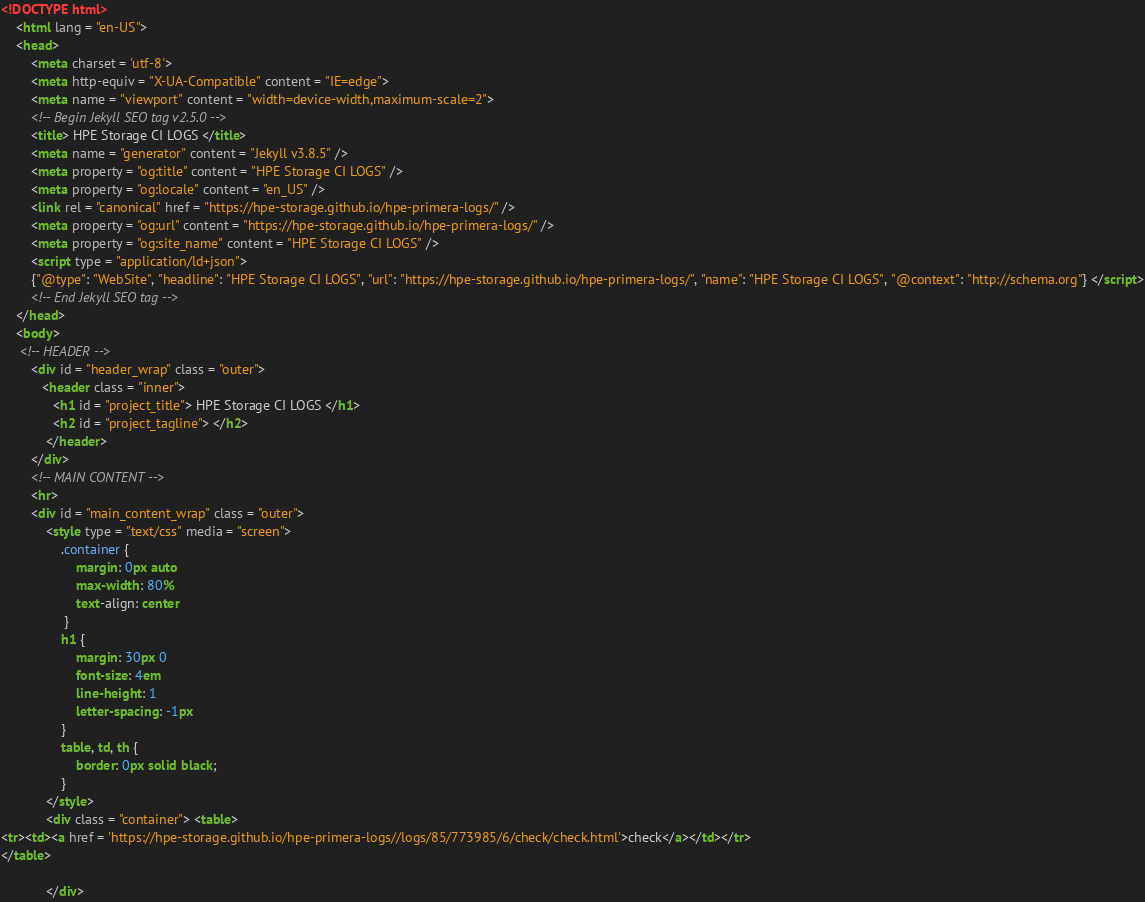Convert code to text. <code><loc_0><loc_0><loc_500><loc_500><_HTML_>
<!DOCTYPE html>
    <html lang = "en-US">
    <head>
        <meta charset = 'utf-8'>
        <meta http-equiv = "X-UA-Compatible" content = "IE=edge">
        <meta name = "viewport" content = "width=device-width,maximum-scale=2">
        <!-- Begin Jekyll SEO tag v2.5.0 -->
        <title> HPE Storage CI LOGS </title>
        <meta name = "generator" content = "Jekyll v3.8.5" />
        <meta property = "og:title" content = "HPE Storage CI LOGS" />
        <meta property = "og:locale" content = "en_US" />
        <link rel = "canonical" href = "https://hpe-storage.github.io/hpe-primera-logs/" />
        <meta property = "og:url" content = "https://hpe-storage.github.io/hpe-primera-logs/" />
        <meta property = "og:site_name" content = "HPE Storage CI LOGS" />
        <script type = "application/ld+json">
        {"@type": "WebSite", "headline": "HPE Storage CI LOGS", "url": "https://hpe-storage.github.io/hpe-primera-logs/", "name": "HPE Storage CI LOGS", "@context": "http://schema.org"} </script>
        <!-- End Jekyll SEO tag -->
    </head>
    <body>
     <!-- HEADER -->
        <div id = "header_wrap" class = "outer">
           <header class = "inner">
              <h1 id = "project_title"> HPE Storage CI LOGS </h1>
              <h2 id = "project_tagline"> </h2>
            </header>
        </div>
        <!-- MAIN CONTENT -->
        <hr>
        <div id = "main_content_wrap" class = "outer">
            <style type = "text/css" media = "screen">
                .container {
                    margin: 0px auto
                    max-width: 80%
                    text-align: center
                 }
                h1 {
                    margin: 30px 0
                    font-size: 4em
                    line-height: 1
                    letter-spacing: -1px
                }
                table, td, th {
                    border: 0px solid black;
                }
            </style>
            <div class = "container"> <table>
<tr><td><a href = 'https://hpe-storage.github.io/hpe-primera-logs//logs/85/773985/6/check/check.html'>check</a></td></tr>
</table>

            </div></code> 